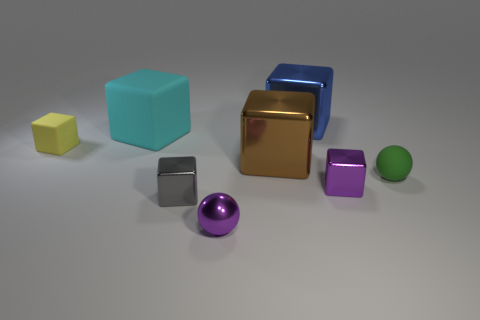Add 1 big cyan matte things. How many objects exist? 9 Subtract all balls. How many objects are left? 6 Subtract all large cyan rubber blocks. How many blocks are left? 5 Add 4 purple spheres. How many purple spheres are left? 5 Add 1 tiny cylinders. How many tiny cylinders exist? 1 Subtract all purple cubes. How many cubes are left? 5 Subtract 0 green cylinders. How many objects are left? 8 Subtract 2 balls. How many balls are left? 0 Subtract all green spheres. Subtract all brown cylinders. How many spheres are left? 1 Subtract all purple spheres. How many brown cubes are left? 1 